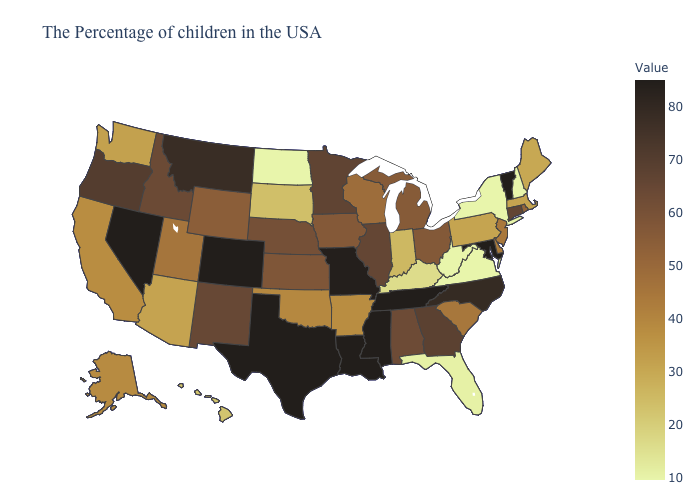Does the map have missing data?
Short answer required. No. Among the states that border New Jersey , does Delaware have the highest value?
Concise answer only. Yes. Among the states that border Illinois , which have the lowest value?
Give a very brief answer. Kentucky. Among the states that border West Virginia , which have the lowest value?
Give a very brief answer. Virginia. Does the map have missing data?
Keep it brief. No. Among the states that border Minnesota , which have the lowest value?
Be succinct. North Dakota. Does North Dakota have the lowest value in the MidWest?
Quick response, please. Yes. Among the states that border New Jersey , does New York have the lowest value?
Quick response, please. Yes. 